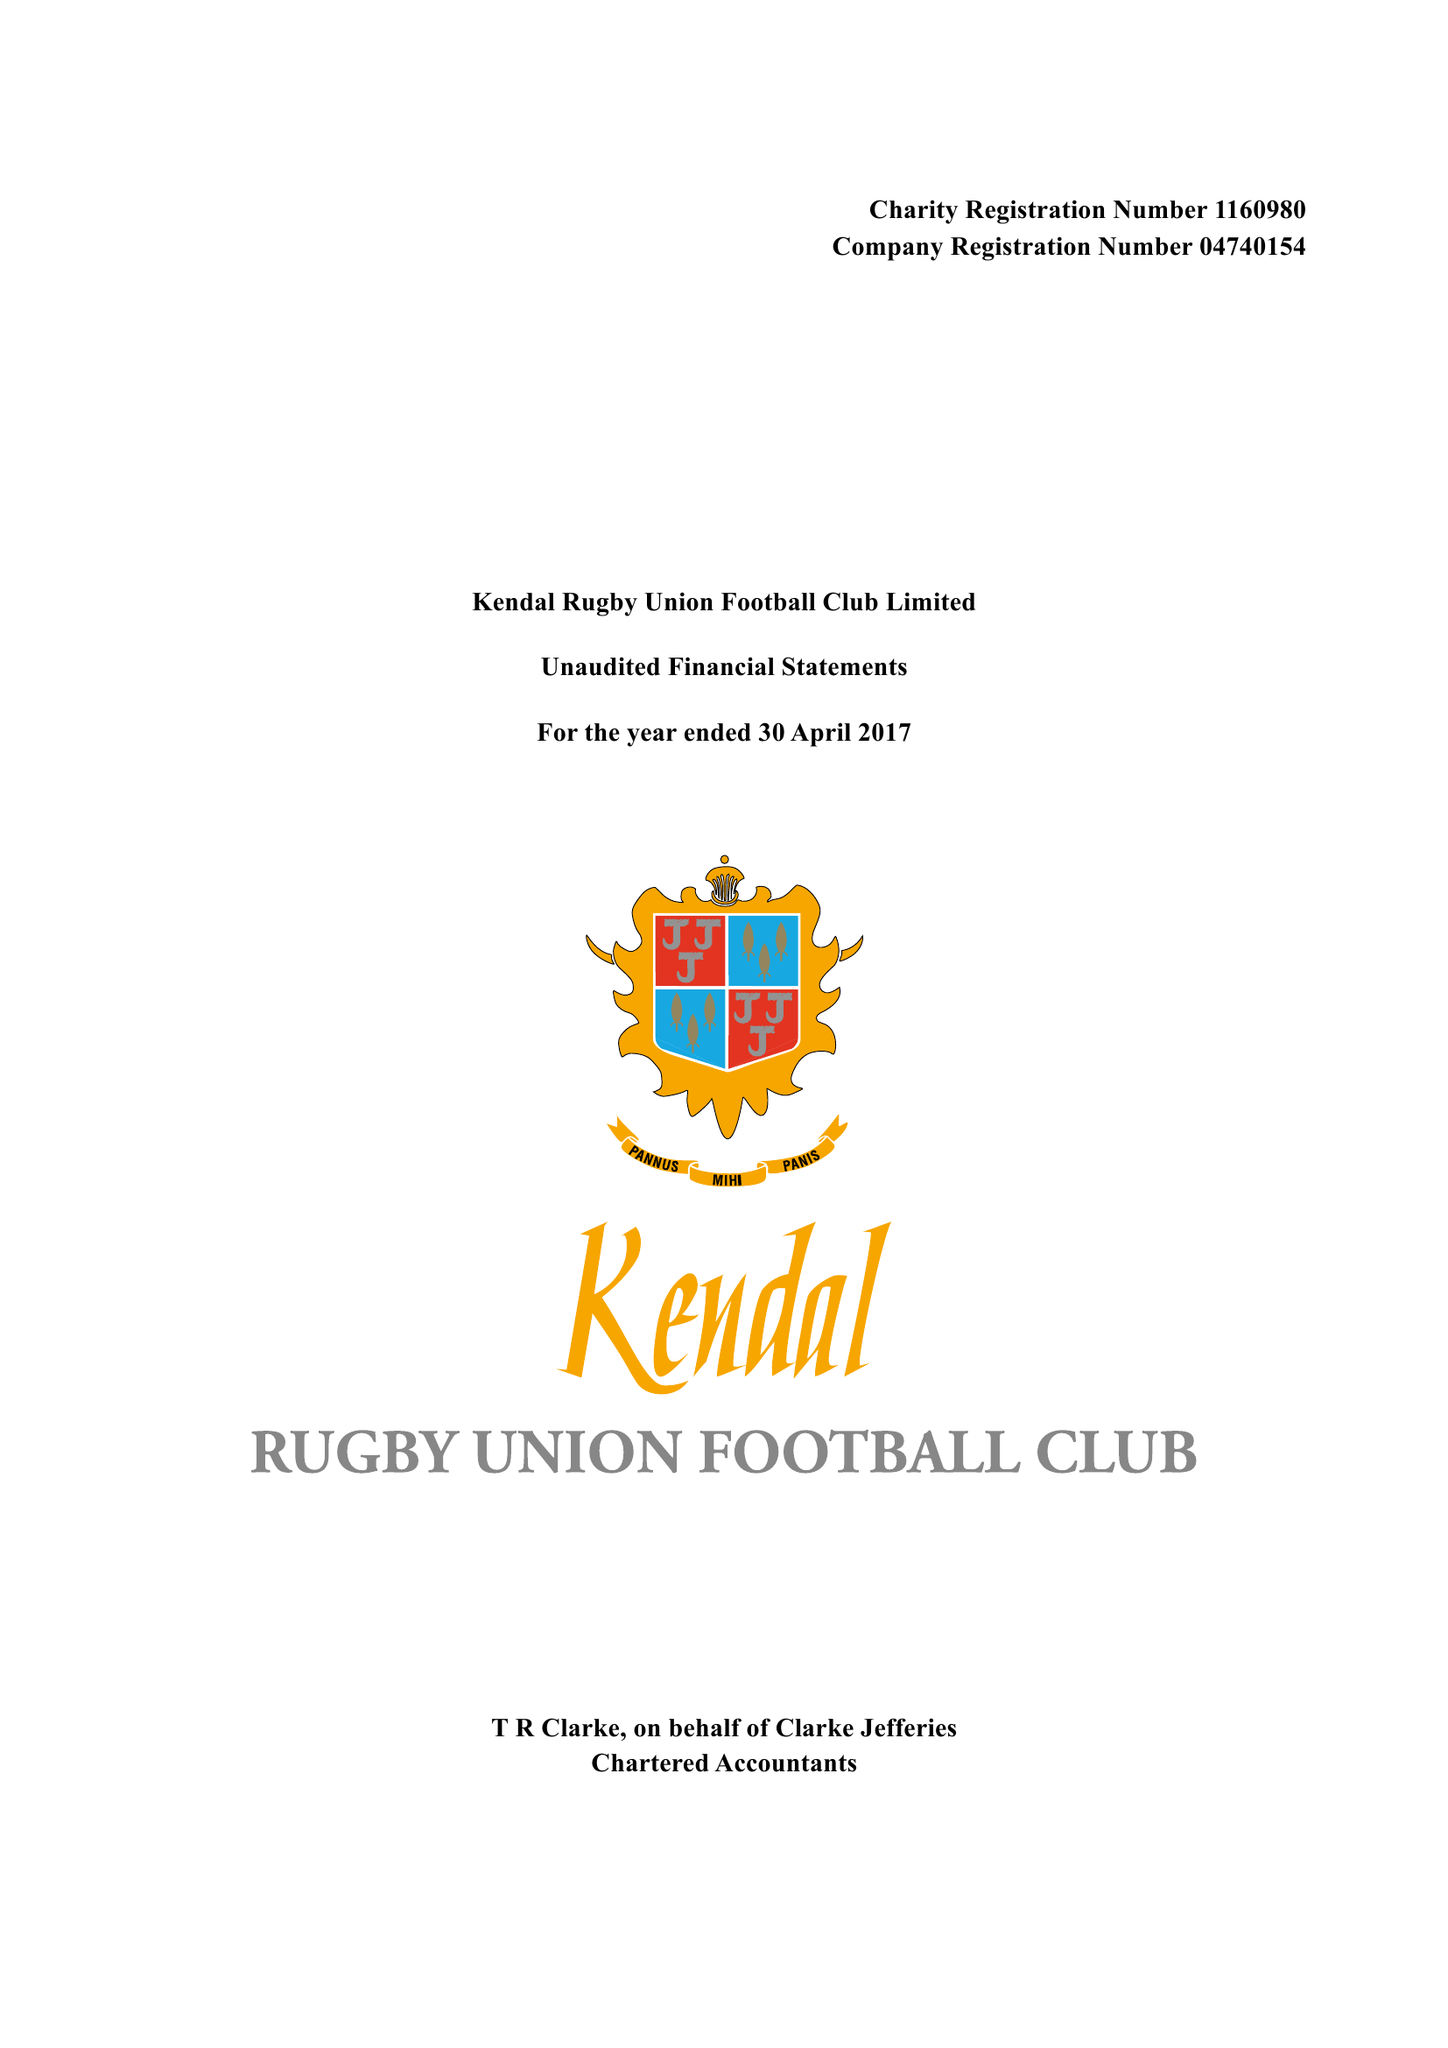What is the value for the address__post_town?
Answer the question using a single word or phrase. KENDAL 